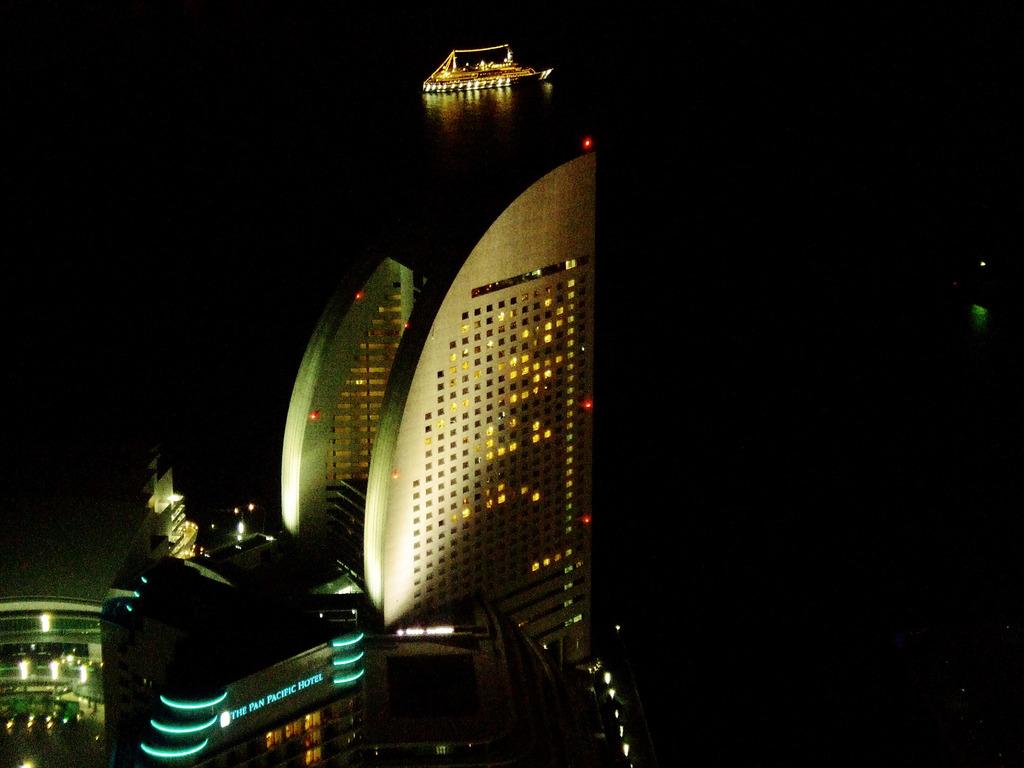Is that the pan pacific hotel?
Your answer should be compact. Yes. 